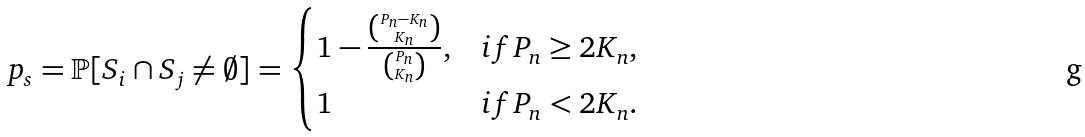Convert formula to latex. <formula><loc_0><loc_0><loc_500><loc_500>p _ { s } & = \mathbb { P } [ S _ { i } \cap S _ { j } \neq \emptyset ] = \begin{cases} 1 - \frac { \binom { P _ { n } - K _ { n } } { K _ { n } } } { \binom { P _ { n } } { K _ { n } } } , & i f P _ { n } \geq 2 K _ { n } , \\ 1 & i f P _ { n } < 2 K _ { n } . \end{cases}</formula> 